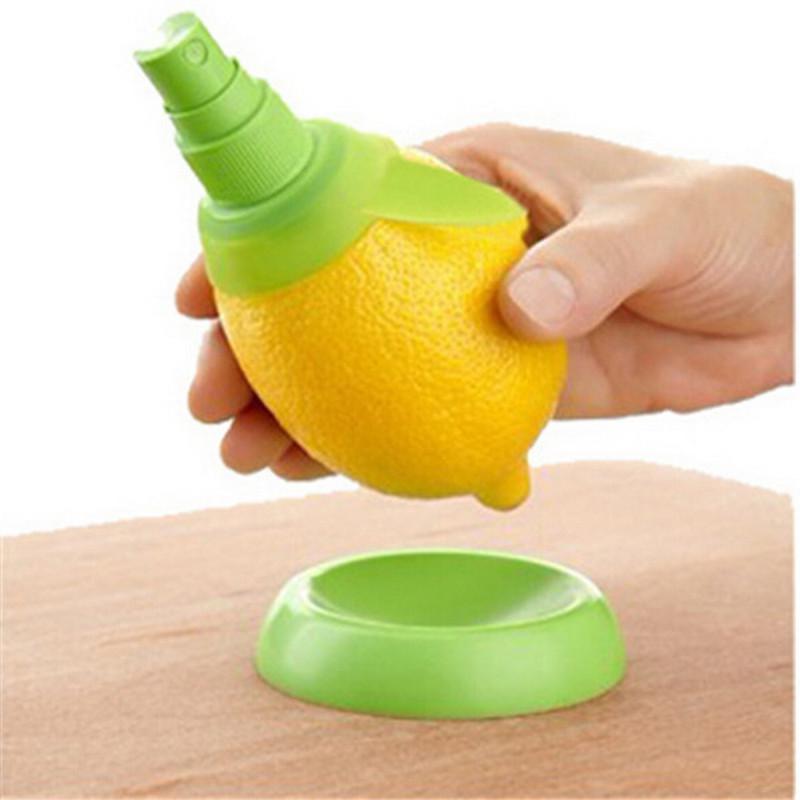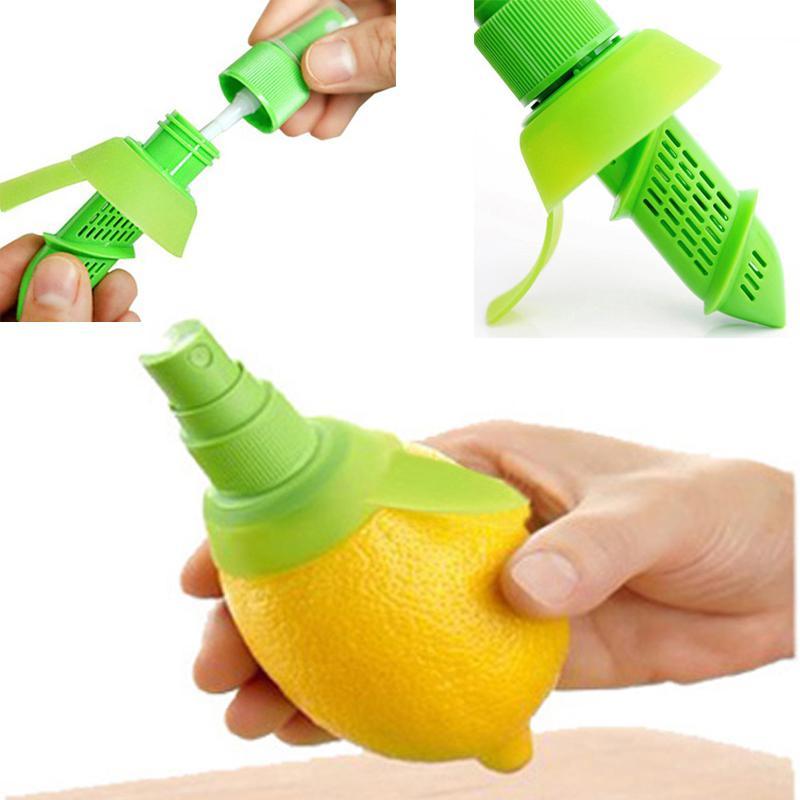The first image is the image on the left, the second image is the image on the right. Analyze the images presented: Is the assertion "In one of the images, a whole lemon is being cut with a knife." valid? Answer yes or no. No. The first image is the image on the left, the second image is the image on the right. For the images displayed, is the sentence "An image contains a lemon being sliced by a knife." factually correct? Answer yes or no. No. 